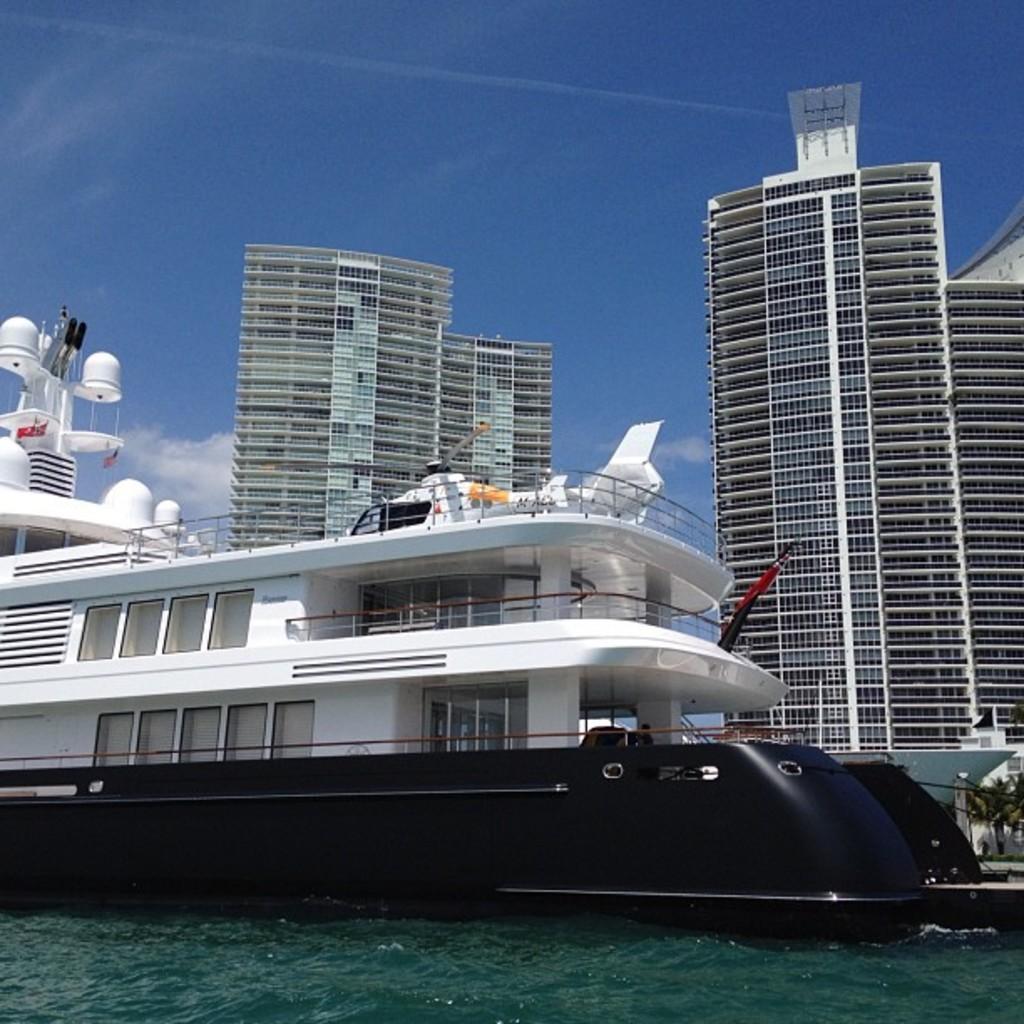Describe this image in one or two sentences. In this image there is the sky towards the top of the image, there are clouds in the sky, there are buildings, there is a ship, there is water towards the bottom of the image. 